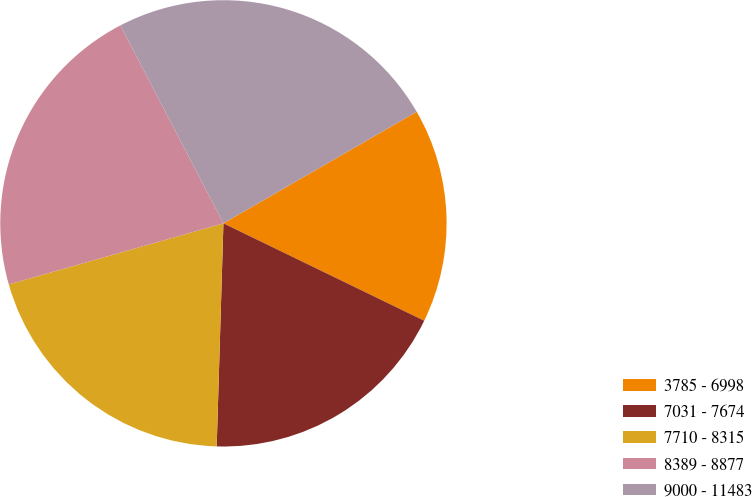Convert chart. <chart><loc_0><loc_0><loc_500><loc_500><pie_chart><fcel>3785 - 6998<fcel>7031 - 7674<fcel>7710 - 8315<fcel>8389 - 8877<fcel>9000 - 11483<nl><fcel>15.52%<fcel>18.29%<fcel>20.11%<fcel>21.77%<fcel>24.3%<nl></chart> 